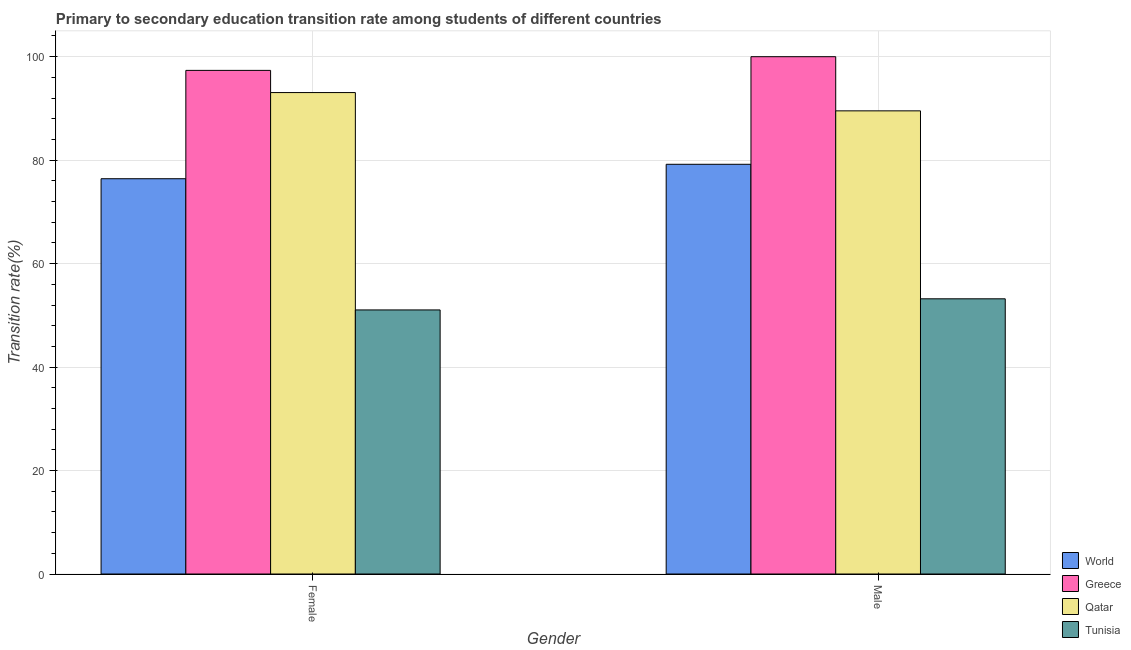What is the label of the 1st group of bars from the left?
Make the answer very short. Female. What is the transition rate among female students in Qatar?
Your answer should be very brief. 93.06. Across all countries, what is the maximum transition rate among male students?
Offer a very short reply. 100. Across all countries, what is the minimum transition rate among male students?
Give a very brief answer. 53.2. In which country was the transition rate among female students maximum?
Keep it short and to the point. Greece. In which country was the transition rate among female students minimum?
Ensure brevity in your answer.  Tunisia. What is the total transition rate among male students in the graph?
Your response must be concise. 321.93. What is the difference between the transition rate among female students in Tunisia and that in Greece?
Your answer should be very brief. -46.31. What is the difference between the transition rate among male students in Greece and the transition rate among female students in Tunisia?
Offer a very short reply. 48.95. What is the average transition rate among male students per country?
Your answer should be very brief. 80.48. What is the difference between the transition rate among male students and transition rate among female students in Qatar?
Make the answer very short. -3.53. What is the ratio of the transition rate among male students in Qatar to that in World?
Offer a very short reply. 1.13. In how many countries, is the transition rate among female students greater than the average transition rate among female students taken over all countries?
Offer a very short reply. 2. What does the 2nd bar from the left in Female represents?
Offer a very short reply. Greece. What does the 1st bar from the right in Male represents?
Keep it short and to the point. Tunisia. What is the difference between two consecutive major ticks on the Y-axis?
Your answer should be very brief. 20. Does the graph contain grids?
Ensure brevity in your answer.  Yes. What is the title of the graph?
Ensure brevity in your answer.  Primary to secondary education transition rate among students of different countries. Does "Lesotho" appear as one of the legend labels in the graph?
Offer a terse response. No. What is the label or title of the Y-axis?
Give a very brief answer. Transition rate(%). What is the Transition rate(%) in World in Female?
Keep it short and to the point. 76.41. What is the Transition rate(%) of Greece in Female?
Ensure brevity in your answer.  97.35. What is the Transition rate(%) of Qatar in Female?
Make the answer very short. 93.06. What is the Transition rate(%) in Tunisia in Female?
Keep it short and to the point. 51.05. What is the Transition rate(%) of World in Male?
Give a very brief answer. 79.2. What is the Transition rate(%) in Greece in Male?
Make the answer very short. 100. What is the Transition rate(%) of Qatar in Male?
Your answer should be compact. 89.53. What is the Transition rate(%) in Tunisia in Male?
Your answer should be very brief. 53.2. Across all Gender, what is the maximum Transition rate(%) of World?
Your answer should be compact. 79.2. Across all Gender, what is the maximum Transition rate(%) of Greece?
Offer a very short reply. 100. Across all Gender, what is the maximum Transition rate(%) in Qatar?
Offer a terse response. 93.06. Across all Gender, what is the maximum Transition rate(%) in Tunisia?
Offer a very short reply. 53.2. Across all Gender, what is the minimum Transition rate(%) in World?
Offer a terse response. 76.41. Across all Gender, what is the minimum Transition rate(%) in Greece?
Your answer should be very brief. 97.35. Across all Gender, what is the minimum Transition rate(%) of Qatar?
Your answer should be very brief. 89.53. Across all Gender, what is the minimum Transition rate(%) in Tunisia?
Provide a short and direct response. 51.05. What is the total Transition rate(%) of World in the graph?
Your answer should be very brief. 155.61. What is the total Transition rate(%) of Greece in the graph?
Give a very brief answer. 197.35. What is the total Transition rate(%) of Qatar in the graph?
Give a very brief answer. 182.59. What is the total Transition rate(%) in Tunisia in the graph?
Offer a terse response. 104.24. What is the difference between the Transition rate(%) of World in Female and that in Male?
Make the answer very short. -2.79. What is the difference between the Transition rate(%) in Greece in Female and that in Male?
Your answer should be compact. -2.65. What is the difference between the Transition rate(%) of Qatar in Female and that in Male?
Offer a terse response. 3.53. What is the difference between the Transition rate(%) in Tunisia in Female and that in Male?
Give a very brief answer. -2.15. What is the difference between the Transition rate(%) in World in Female and the Transition rate(%) in Greece in Male?
Your answer should be very brief. -23.59. What is the difference between the Transition rate(%) in World in Female and the Transition rate(%) in Qatar in Male?
Give a very brief answer. -13.12. What is the difference between the Transition rate(%) in World in Female and the Transition rate(%) in Tunisia in Male?
Offer a very short reply. 23.21. What is the difference between the Transition rate(%) in Greece in Female and the Transition rate(%) in Qatar in Male?
Offer a terse response. 7.82. What is the difference between the Transition rate(%) in Greece in Female and the Transition rate(%) in Tunisia in Male?
Your answer should be very brief. 44.16. What is the difference between the Transition rate(%) in Qatar in Female and the Transition rate(%) in Tunisia in Male?
Your answer should be very brief. 39.87. What is the average Transition rate(%) in World per Gender?
Offer a very short reply. 77.8. What is the average Transition rate(%) of Greece per Gender?
Provide a succinct answer. 98.68. What is the average Transition rate(%) of Qatar per Gender?
Your answer should be compact. 91.3. What is the average Transition rate(%) of Tunisia per Gender?
Keep it short and to the point. 52.12. What is the difference between the Transition rate(%) of World and Transition rate(%) of Greece in Female?
Make the answer very short. -20.95. What is the difference between the Transition rate(%) in World and Transition rate(%) in Qatar in Female?
Your answer should be very brief. -16.66. What is the difference between the Transition rate(%) in World and Transition rate(%) in Tunisia in Female?
Your answer should be compact. 25.36. What is the difference between the Transition rate(%) in Greece and Transition rate(%) in Qatar in Female?
Keep it short and to the point. 4.29. What is the difference between the Transition rate(%) of Greece and Transition rate(%) of Tunisia in Female?
Make the answer very short. 46.31. What is the difference between the Transition rate(%) in Qatar and Transition rate(%) in Tunisia in Female?
Your answer should be compact. 42.02. What is the difference between the Transition rate(%) of World and Transition rate(%) of Greece in Male?
Make the answer very short. -20.8. What is the difference between the Transition rate(%) in World and Transition rate(%) in Qatar in Male?
Offer a very short reply. -10.33. What is the difference between the Transition rate(%) of World and Transition rate(%) of Tunisia in Male?
Your answer should be very brief. 26. What is the difference between the Transition rate(%) in Greece and Transition rate(%) in Qatar in Male?
Your answer should be very brief. 10.47. What is the difference between the Transition rate(%) in Greece and Transition rate(%) in Tunisia in Male?
Provide a succinct answer. 46.8. What is the difference between the Transition rate(%) in Qatar and Transition rate(%) in Tunisia in Male?
Give a very brief answer. 36.33. What is the ratio of the Transition rate(%) in World in Female to that in Male?
Ensure brevity in your answer.  0.96. What is the ratio of the Transition rate(%) in Greece in Female to that in Male?
Provide a short and direct response. 0.97. What is the ratio of the Transition rate(%) of Qatar in Female to that in Male?
Offer a very short reply. 1.04. What is the ratio of the Transition rate(%) in Tunisia in Female to that in Male?
Provide a short and direct response. 0.96. What is the difference between the highest and the second highest Transition rate(%) in World?
Make the answer very short. 2.79. What is the difference between the highest and the second highest Transition rate(%) in Greece?
Your answer should be compact. 2.65. What is the difference between the highest and the second highest Transition rate(%) of Qatar?
Your answer should be very brief. 3.53. What is the difference between the highest and the second highest Transition rate(%) in Tunisia?
Offer a terse response. 2.15. What is the difference between the highest and the lowest Transition rate(%) of World?
Offer a terse response. 2.79. What is the difference between the highest and the lowest Transition rate(%) of Greece?
Provide a succinct answer. 2.65. What is the difference between the highest and the lowest Transition rate(%) in Qatar?
Ensure brevity in your answer.  3.53. What is the difference between the highest and the lowest Transition rate(%) of Tunisia?
Your response must be concise. 2.15. 